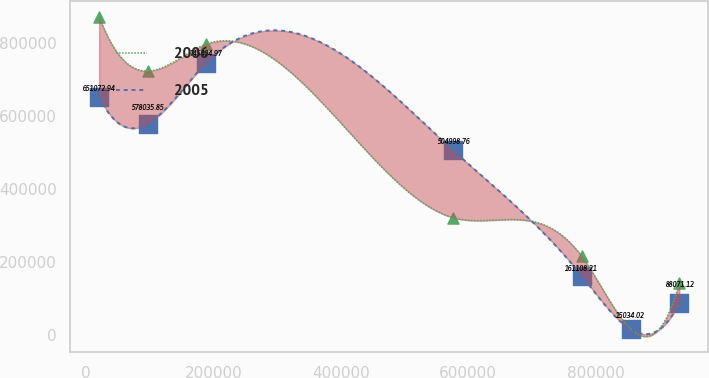Convert chart. <chart><loc_0><loc_0><loc_500><loc_500><line_chart><ecel><fcel>2006<fcel>2005<nl><fcel>20347.7<fcel>869931<fcel>651073<nl><fcel>96951.2<fcel>722254<fcel>578036<nl><fcel>188870<fcel>796093<fcel>745405<nl><fcel>576568<fcel>320759<fcel>504999<nl><fcel>778674<fcel>214486<fcel>161108<nl><fcel>855277<fcel>16228.8<fcel>15034<nl><fcel>931881<fcel>140648<fcel>88071.1<nl></chart> 